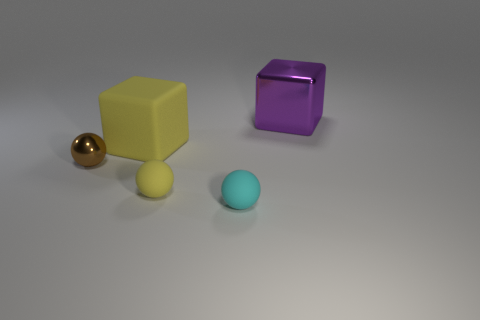Are there any objects in the image that could be considered small? Yes, there are two smaller objects in the image: a small metallic sphere and a small pale yellow sphere that could be a ball. Both have smoother surfaces and reflect light to some extent. Which one of the smaller objects seems more reflective? The small metallic sphere appears to be more reflective, with a mirror-like surface that reflects its surroundings clearly, including the pale yellow sphere and the large blocks. 